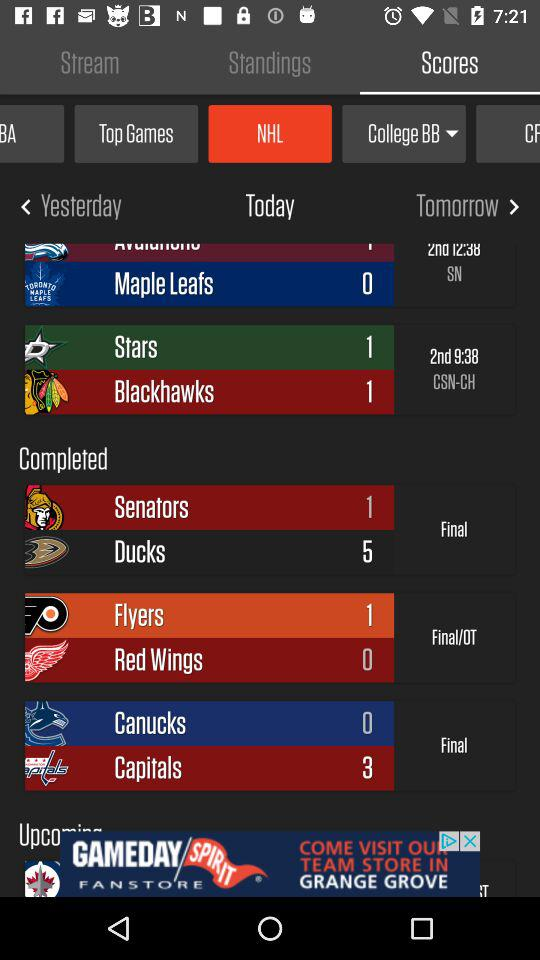Which tab is selected? The selected tabs are "Scores", "NHL" and "Today". 